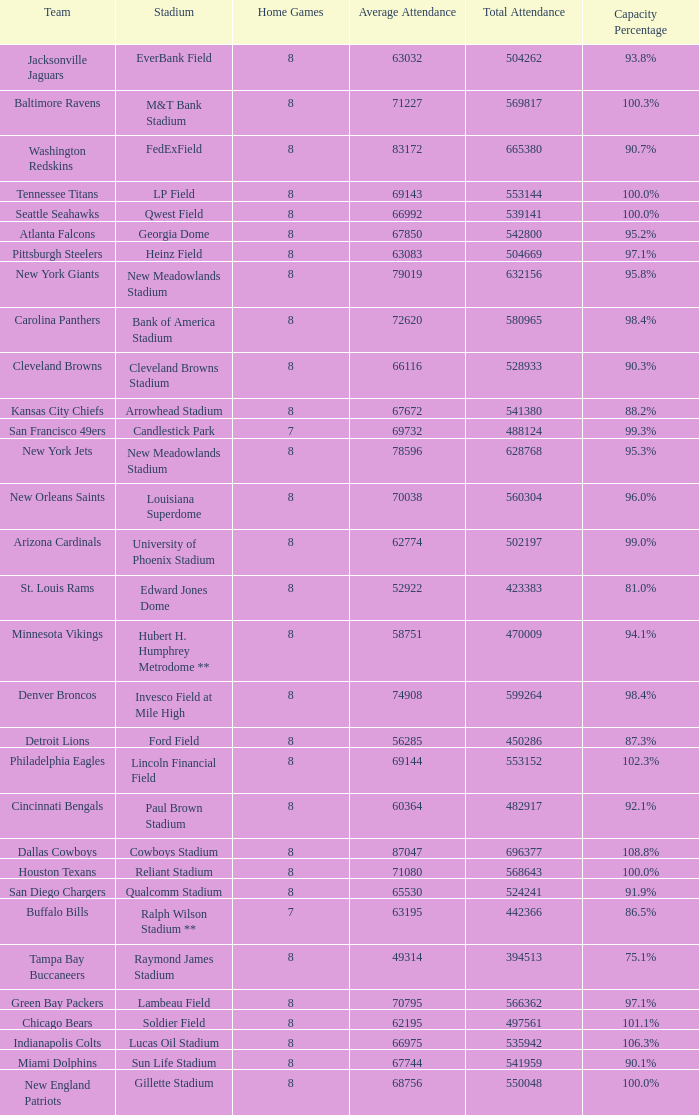What was the capacity for the Denver Broncos? 98.4%. 